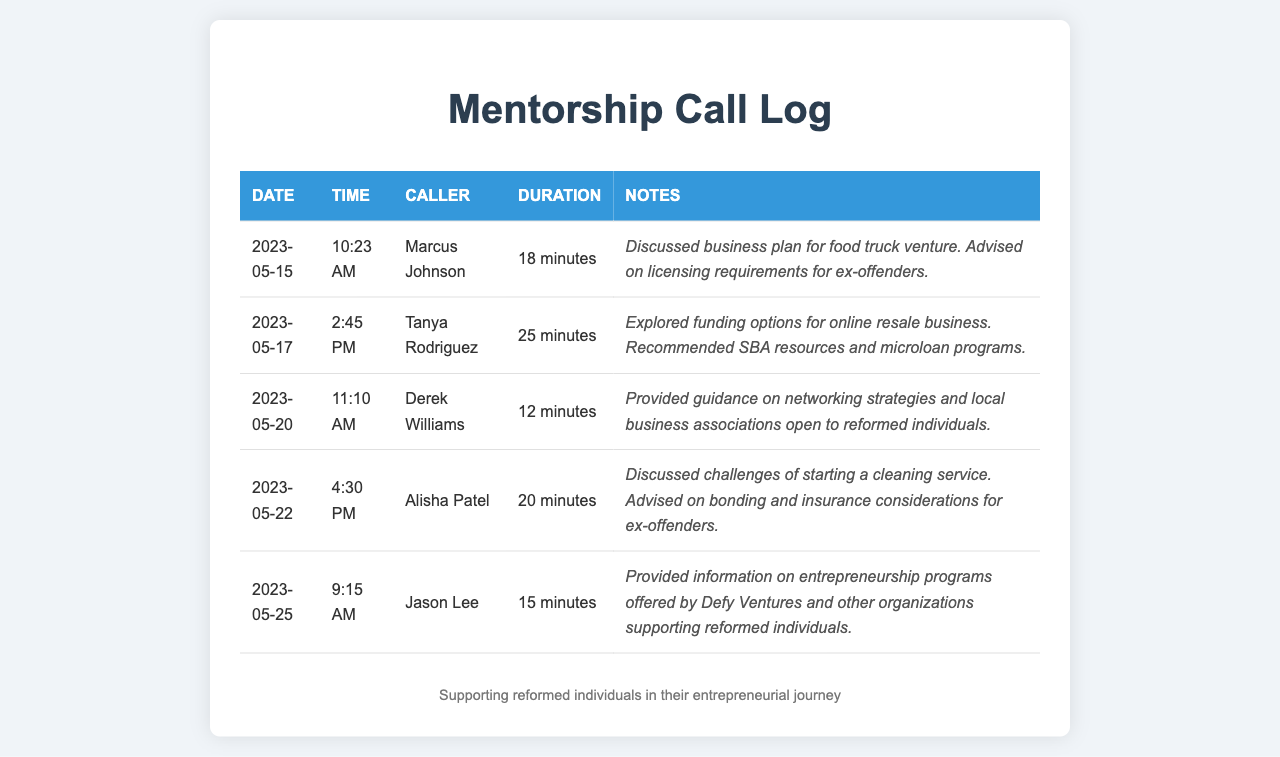what is the date of the first call logged? The first call in the log was made on May 15, 2023.
Answer: May 15, 2023 how long was the call with Tanya Rodriguez? The duration of Tanya Rodriguez's call was 25 minutes.
Answer: 25 minutes who discussed challenges in starting a cleaning service? Alisha Patel discussed the challenges related to starting a cleaning service during her call.
Answer: Alisha Patel what business type did Marcus Johnson inquire about? Marcus Johnson called to discuss a business plan for a food truck venture.
Answer: food truck what organization was mentioned for supporting reformed individuals? Defy Ventures was mentioned as an organization supporting reformed individuals in entrepreneurship.
Answer: Defy Ventures what was the main topic of discussion with Derek Williams? The main topic discussed with Derek Williams was networking strategies and local business associations.
Answer: networking strategies how many minutes did Jason Lee's call last? Jason Lee's call lasted for 15 minutes.
Answer: 15 minutes which call had the shortest duration? The shortest call recorded was with Derek Williams, lasting 12 minutes.
Answer: 12 minutes what funding options were explored during Tanya Rodriguez's call? Funding options for an online resale business were explored during Tanya Rodriguez's call.
Answer: online resale business 